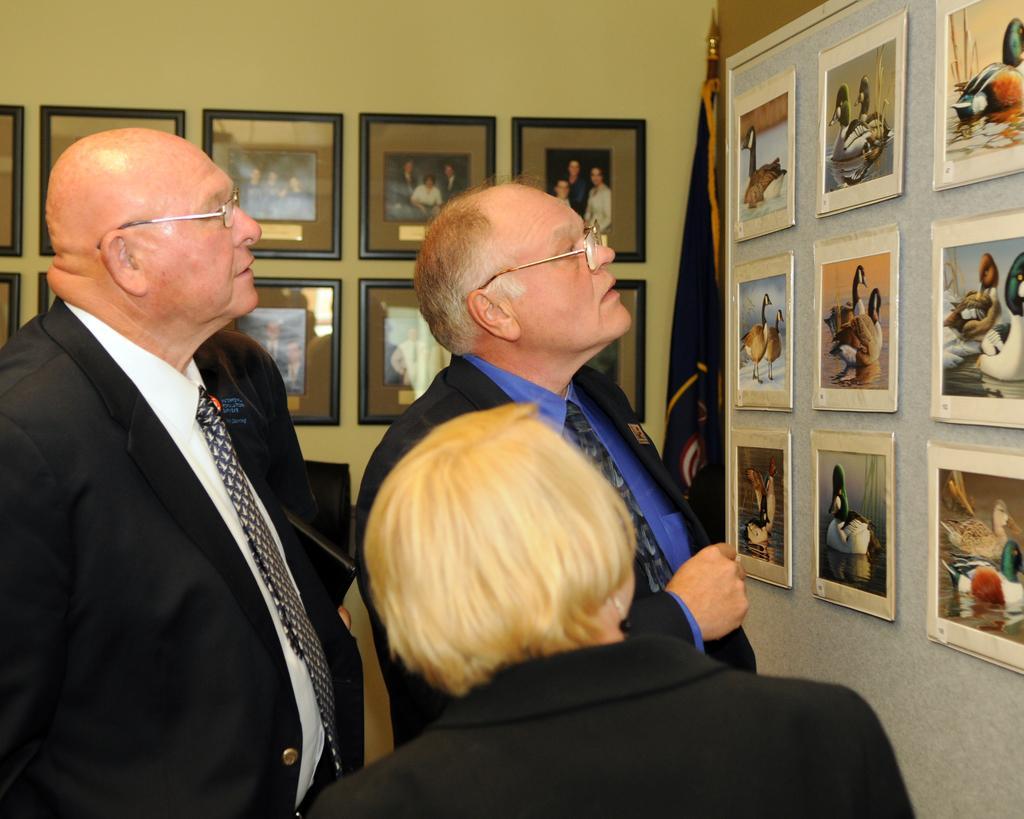Please provide a concise description of this image. This picture describes about group of people, few people wore spectacles, in front of them we can see a flag and few frames on the walls. 